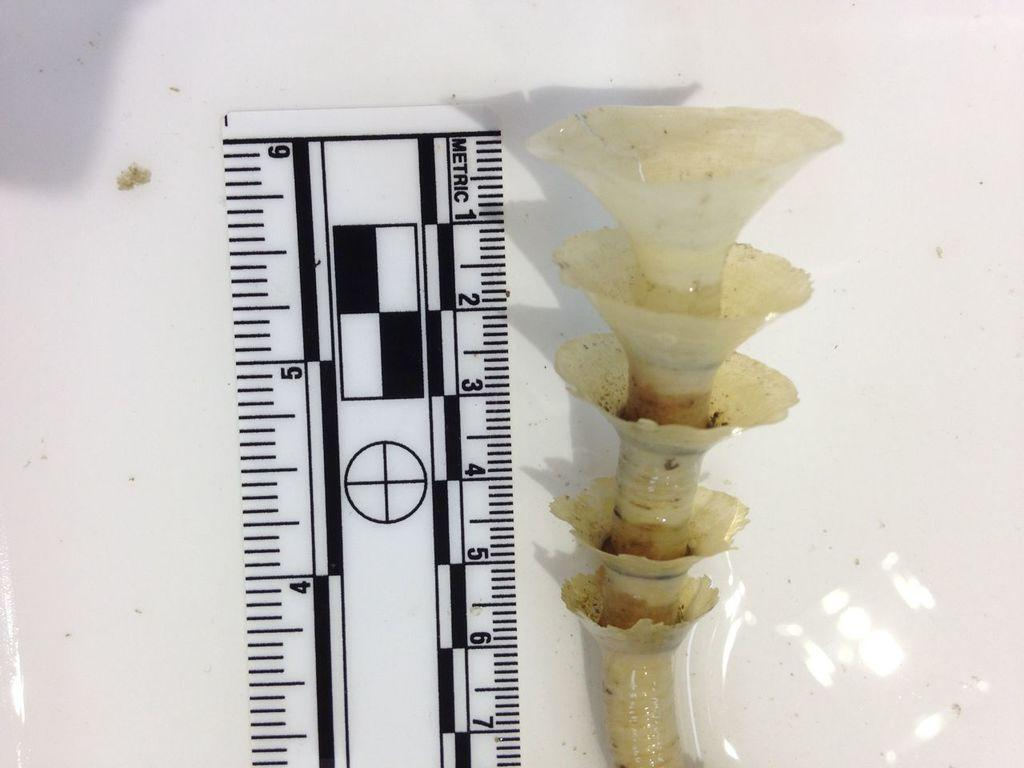<image>
Provide a brief description of the given image. Ruler that says Metric on it measuring a weird object. 